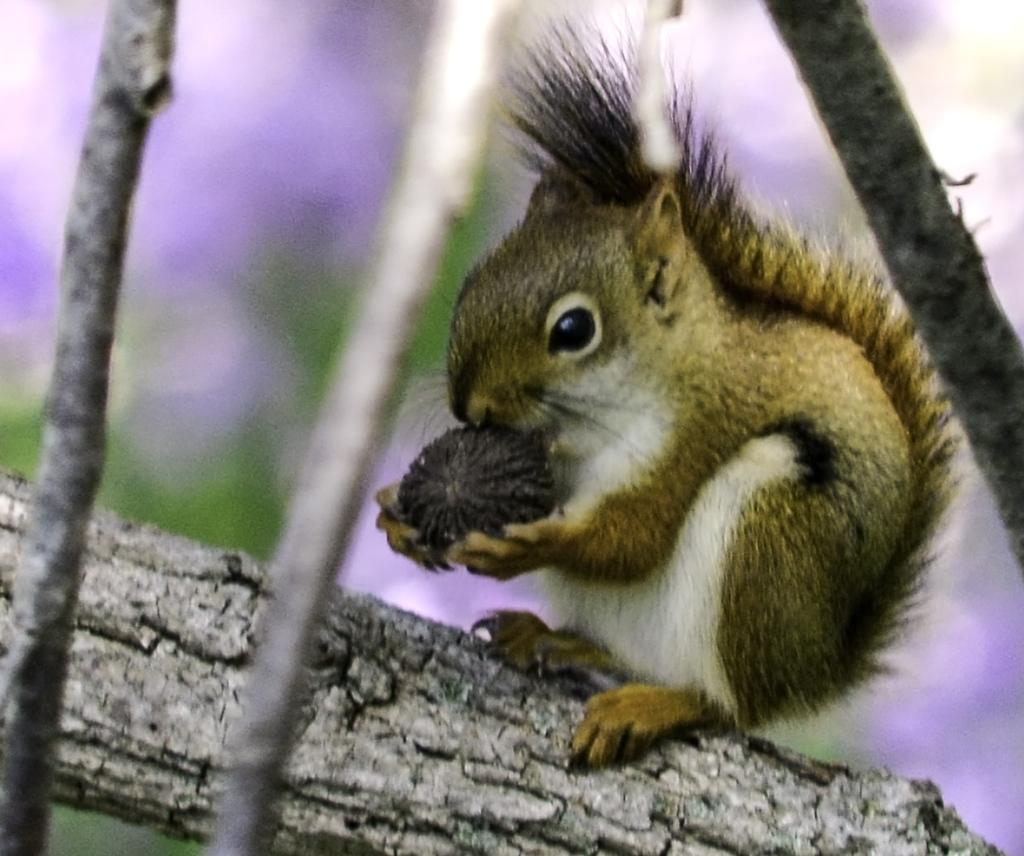What animal is present in the image? There is a squirrel in the image. Where is the squirrel located? The squirrel is sitting on a tree branch. What can be seen in the background of the image? There are plants visible in the backdrop of the image. What type of salt can be seen on the shop's paper in the image? There is no salt, shop, or paper present in the image; it features a squirrel sitting on a tree branch with plants in the background. 